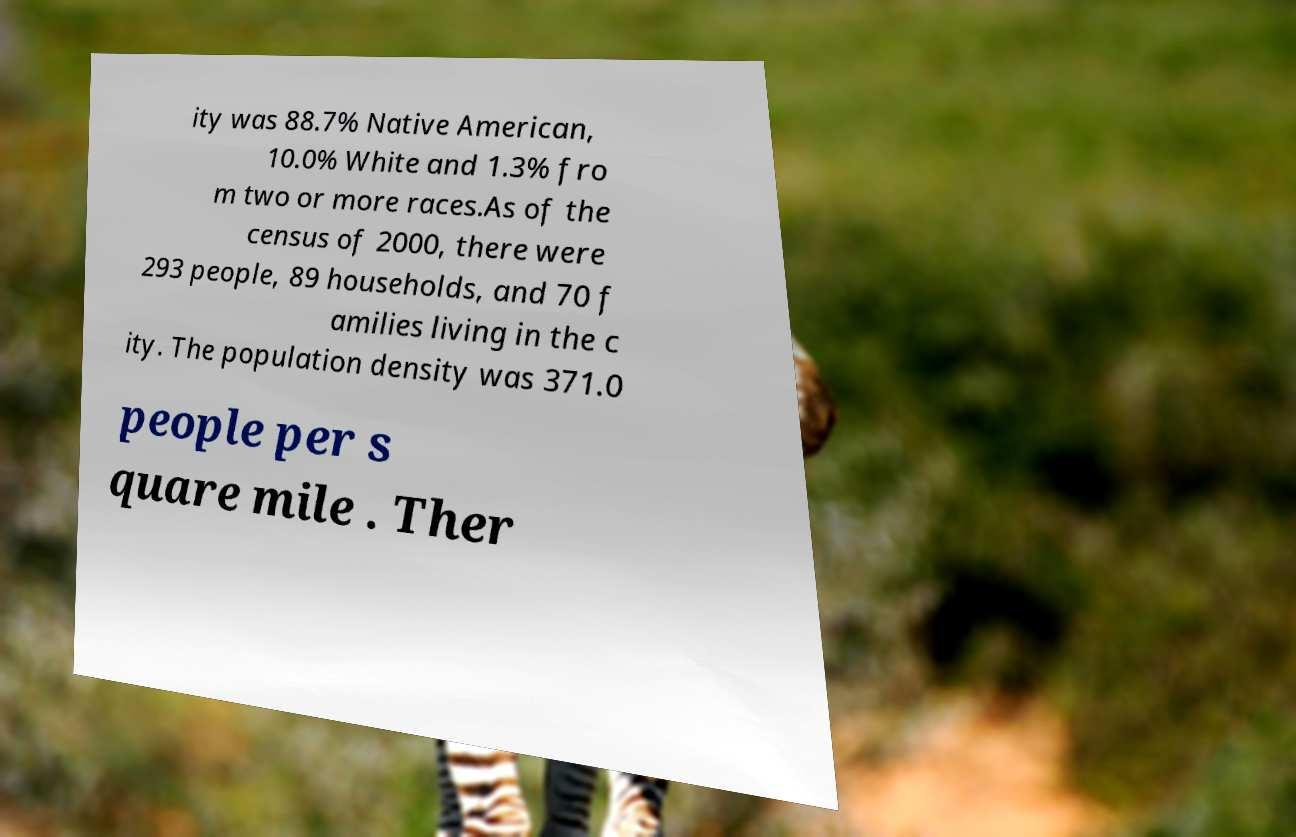Could you extract and type out the text from this image? ity was 88.7% Native American, 10.0% White and 1.3% fro m two or more races.As of the census of 2000, there were 293 people, 89 households, and 70 f amilies living in the c ity. The population density was 371.0 people per s quare mile . Ther 